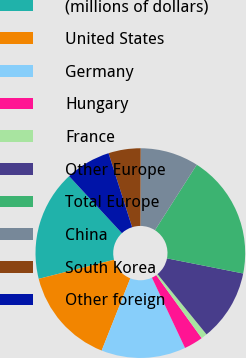<chart> <loc_0><loc_0><loc_500><loc_500><pie_chart><fcel>(millions of dollars)<fcel>United States<fcel>Germany<fcel>Hungary<fcel>France<fcel>Other Europe<fcel>Total Europe<fcel>China<fcel>South Korea<fcel>Other foreign<nl><fcel>17.06%<fcel>15.04%<fcel>13.02%<fcel>2.94%<fcel>0.93%<fcel>11.01%<fcel>19.07%<fcel>8.99%<fcel>4.96%<fcel>6.98%<nl></chart> 